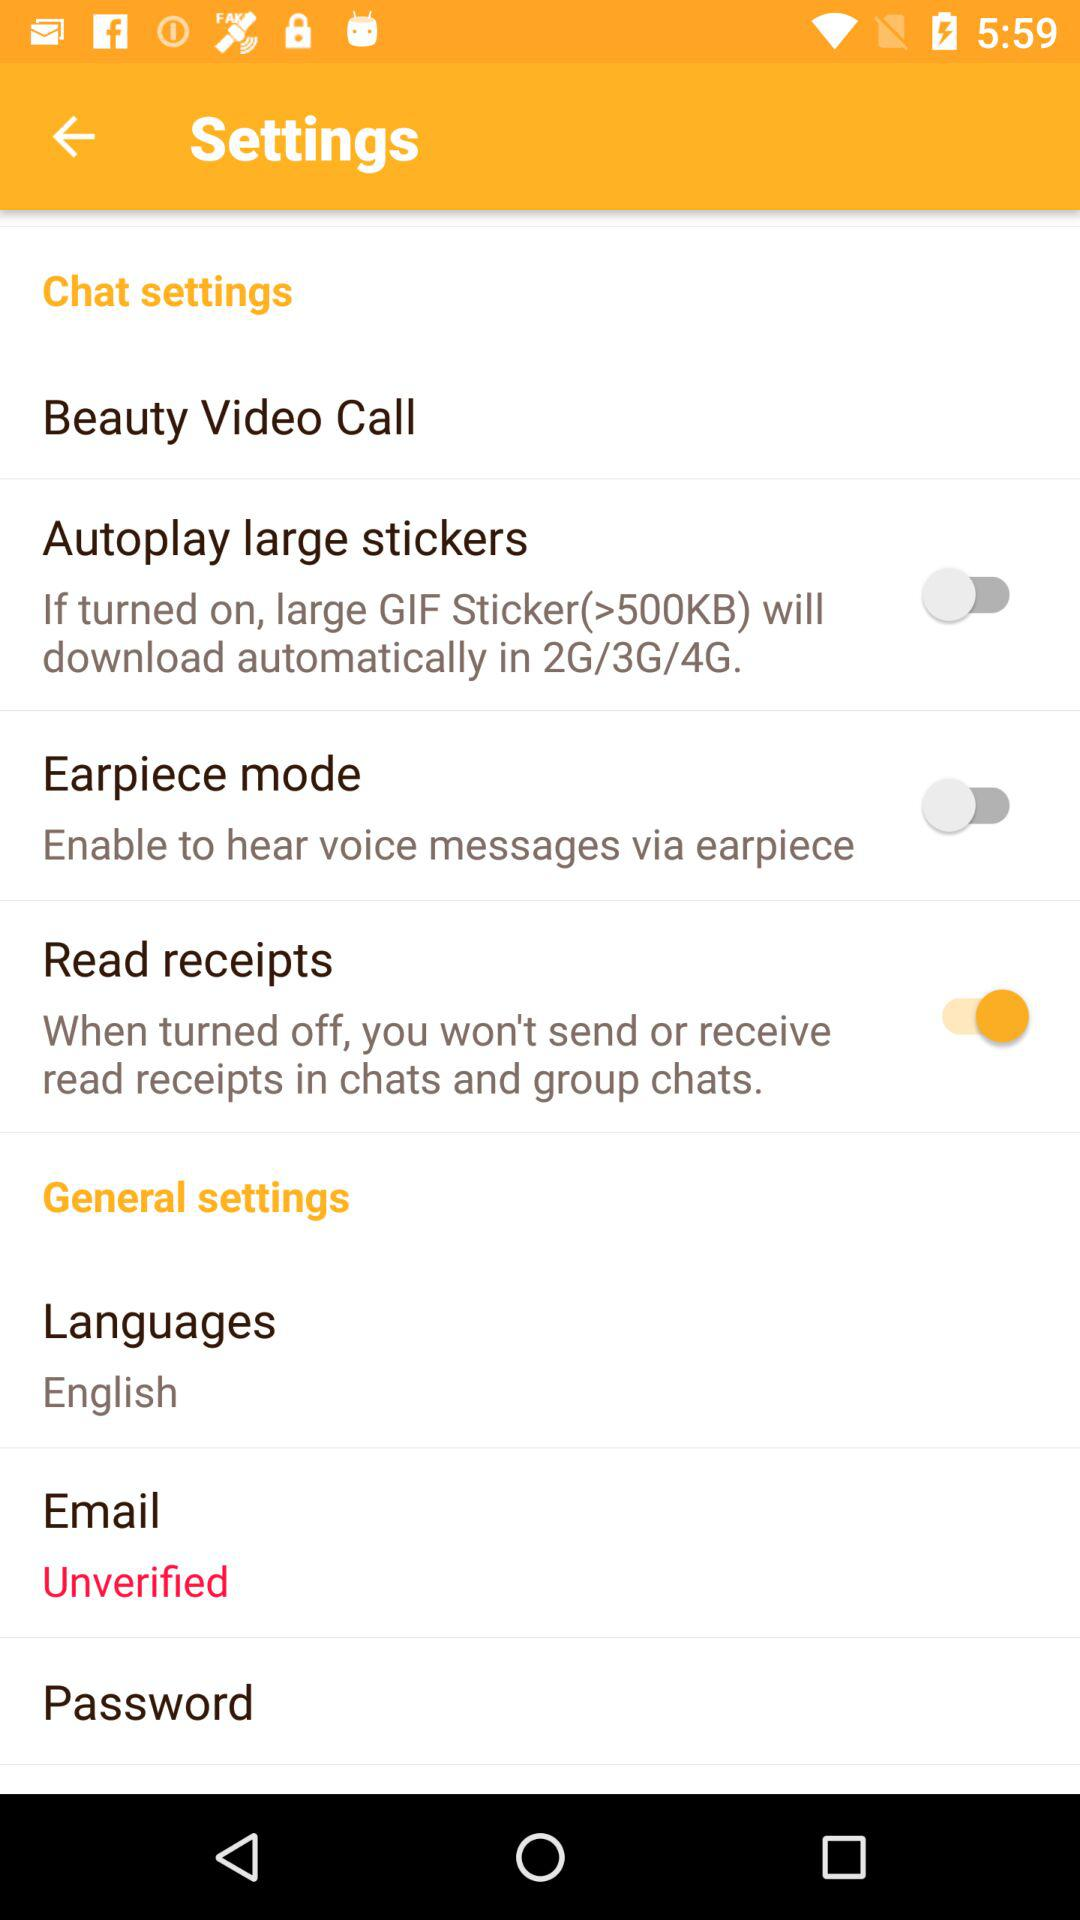Is "Email" verified or not?
Answer the question using a single word or phrase. "Email" is unverified. 